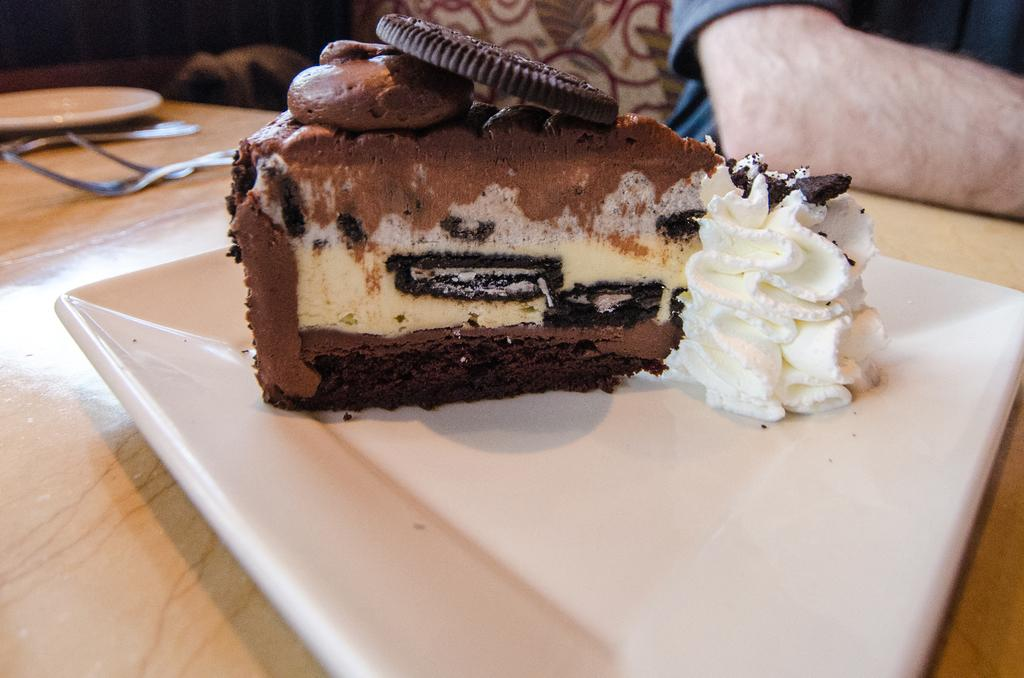What type of surface is visible in the image? There is a wooden surface in the image. What is placed on the wooden surface? There is a white plate on the wooden surface. What is on the plate? There is a piece of cake on the plate. What utensils can be seen in the image? There are spoons visible in the image. Whose hand is present in the image? A human hand is present in the image. What type of organization is depicted on the piece of cake? There is no organization depicted on the piece of cake; it is a dessert item. 